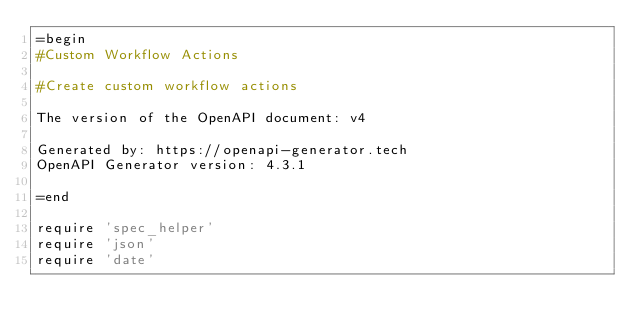<code> <loc_0><loc_0><loc_500><loc_500><_Ruby_>=begin
#Custom Workflow Actions

#Create custom workflow actions

The version of the OpenAPI document: v4

Generated by: https://openapi-generator.tech
OpenAPI Generator version: 4.3.1

=end

require 'spec_helper'
require 'json'
require 'date'
</code> 